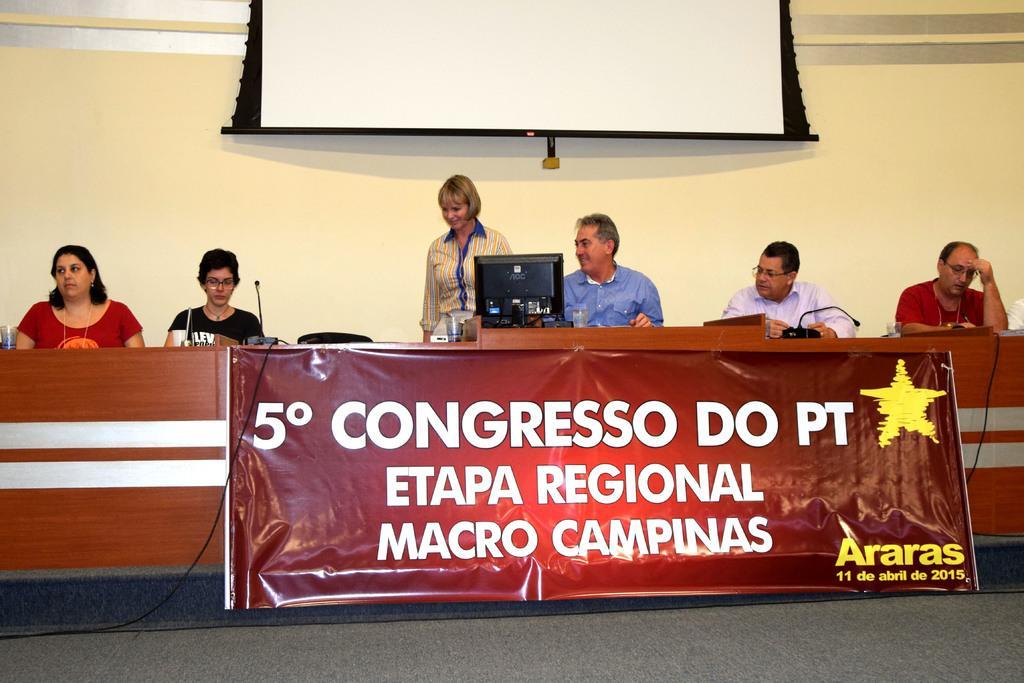In one or two sentences, can you explain what this image depicts? In this image we can see some people sitting. And we can see the white screen. And we can see the monitor, microphone and some objects on the table. And we can see a banner with some text on it. 